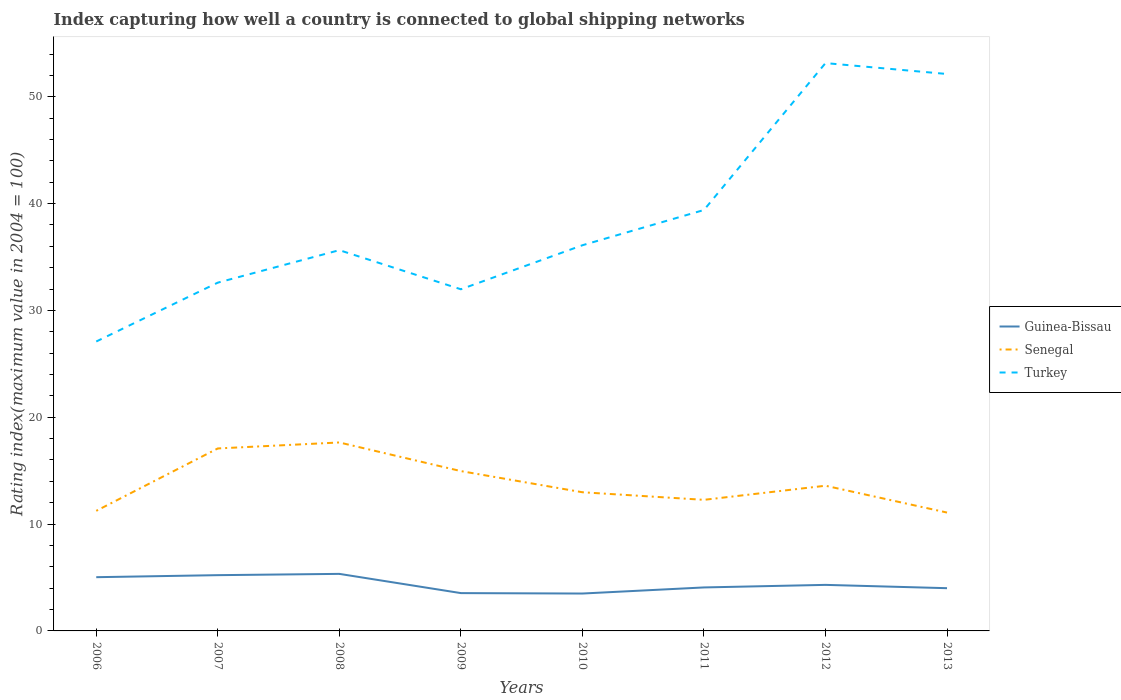How many different coloured lines are there?
Your response must be concise. 3. Across all years, what is the maximum rating index in Turkey?
Provide a short and direct response. 27.09. What is the total rating index in Guinea-Bissau in the graph?
Offer a very short reply. 1.22. What is the difference between the highest and the second highest rating index in Turkey?
Offer a terse response. 26.06. What is the difference between the highest and the lowest rating index in Turkey?
Make the answer very short. 3. How many lines are there?
Your answer should be compact. 3. How many years are there in the graph?
Your answer should be very brief. 8. Are the values on the major ticks of Y-axis written in scientific E-notation?
Offer a very short reply. No. Does the graph contain any zero values?
Ensure brevity in your answer.  No. Does the graph contain grids?
Your answer should be very brief. No. Where does the legend appear in the graph?
Your answer should be compact. Center right. How are the legend labels stacked?
Provide a short and direct response. Vertical. What is the title of the graph?
Offer a terse response. Index capturing how well a country is connected to global shipping networks. What is the label or title of the Y-axis?
Keep it short and to the point. Rating index(maximum value in 2004 = 100). What is the Rating index(maximum value in 2004 = 100) of Guinea-Bissau in 2006?
Offer a very short reply. 5.03. What is the Rating index(maximum value in 2004 = 100) of Senegal in 2006?
Ensure brevity in your answer.  11.24. What is the Rating index(maximum value in 2004 = 100) in Turkey in 2006?
Your answer should be very brief. 27.09. What is the Rating index(maximum value in 2004 = 100) of Guinea-Bissau in 2007?
Offer a terse response. 5.22. What is the Rating index(maximum value in 2004 = 100) in Senegal in 2007?
Give a very brief answer. 17.08. What is the Rating index(maximum value in 2004 = 100) of Turkey in 2007?
Give a very brief answer. 32.6. What is the Rating index(maximum value in 2004 = 100) of Guinea-Bissau in 2008?
Offer a terse response. 5.34. What is the Rating index(maximum value in 2004 = 100) in Senegal in 2008?
Offer a very short reply. 17.64. What is the Rating index(maximum value in 2004 = 100) of Turkey in 2008?
Your answer should be very brief. 35.64. What is the Rating index(maximum value in 2004 = 100) of Guinea-Bissau in 2009?
Make the answer very short. 3.54. What is the Rating index(maximum value in 2004 = 100) in Senegal in 2009?
Your answer should be very brief. 14.96. What is the Rating index(maximum value in 2004 = 100) of Turkey in 2009?
Keep it short and to the point. 31.98. What is the Rating index(maximum value in 2004 = 100) in Guinea-Bissau in 2010?
Make the answer very short. 3.5. What is the Rating index(maximum value in 2004 = 100) in Senegal in 2010?
Offer a very short reply. 12.98. What is the Rating index(maximum value in 2004 = 100) of Turkey in 2010?
Your answer should be compact. 36.1. What is the Rating index(maximum value in 2004 = 100) in Guinea-Bissau in 2011?
Your answer should be compact. 4.07. What is the Rating index(maximum value in 2004 = 100) of Senegal in 2011?
Offer a very short reply. 12.27. What is the Rating index(maximum value in 2004 = 100) in Turkey in 2011?
Offer a terse response. 39.4. What is the Rating index(maximum value in 2004 = 100) of Guinea-Bissau in 2012?
Provide a succinct answer. 4.31. What is the Rating index(maximum value in 2004 = 100) of Senegal in 2012?
Your response must be concise. 13.59. What is the Rating index(maximum value in 2004 = 100) in Turkey in 2012?
Your answer should be compact. 53.15. What is the Rating index(maximum value in 2004 = 100) in Guinea-Bissau in 2013?
Your response must be concise. 4. What is the Rating index(maximum value in 2004 = 100) of Senegal in 2013?
Your answer should be compact. 11.08. What is the Rating index(maximum value in 2004 = 100) of Turkey in 2013?
Your answer should be compact. 52.13. Across all years, what is the maximum Rating index(maximum value in 2004 = 100) of Guinea-Bissau?
Give a very brief answer. 5.34. Across all years, what is the maximum Rating index(maximum value in 2004 = 100) in Senegal?
Your answer should be very brief. 17.64. Across all years, what is the maximum Rating index(maximum value in 2004 = 100) in Turkey?
Your answer should be compact. 53.15. Across all years, what is the minimum Rating index(maximum value in 2004 = 100) in Guinea-Bissau?
Your answer should be very brief. 3.5. Across all years, what is the minimum Rating index(maximum value in 2004 = 100) of Senegal?
Ensure brevity in your answer.  11.08. Across all years, what is the minimum Rating index(maximum value in 2004 = 100) of Turkey?
Ensure brevity in your answer.  27.09. What is the total Rating index(maximum value in 2004 = 100) of Guinea-Bissau in the graph?
Keep it short and to the point. 35.01. What is the total Rating index(maximum value in 2004 = 100) of Senegal in the graph?
Your answer should be compact. 110.84. What is the total Rating index(maximum value in 2004 = 100) of Turkey in the graph?
Your answer should be compact. 308.09. What is the difference between the Rating index(maximum value in 2004 = 100) in Guinea-Bissau in 2006 and that in 2007?
Make the answer very short. -0.19. What is the difference between the Rating index(maximum value in 2004 = 100) of Senegal in 2006 and that in 2007?
Ensure brevity in your answer.  -5.84. What is the difference between the Rating index(maximum value in 2004 = 100) in Turkey in 2006 and that in 2007?
Provide a short and direct response. -5.51. What is the difference between the Rating index(maximum value in 2004 = 100) of Guinea-Bissau in 2006 and that in 2008?
Your answer should be compact. -0.31. What is the difference between the Rating index(maximum value in 2004 = 100) of Senegal in 2006 and that in 2008?
Provide a short and direct response. -6.4. What is the difference between the Rating index(maximum value in 2004 = 100) of Turkey in 2006 and that in 2008?
Make the answer very short. -8.55. What is the difference between the Rating index(maximum value in 2004 = 100) of Guinea-Bissau in 2006 and that in 2009?
Your answer should be compact. 1.49. What is the difference between the Rating index(maximum value in 2004 = 100) in Senegal in 2006 and that in 2009?
Provide a short and direct response. -3.72. What is the difference between the Rating index(maximum value in 2004 = 100) in Turkey in 2006 and that in 2009?
Your answer should be compact. -4.89. What is the difference between the Rating index(maximum value in 2004 = 100) in Guinea-Bissau in 2006 and that in 2010?
Your answer should be very brief. 1.53. What is the difference between the Rating index(maximum value in 2004 = 100) in Senegal in 2006 and that in 2010?
Provide a succinct answer. -1.74. What is the difference between the Rating index(maximum value in 2004 = 100) in Turkey in 2006 and that in 2010?
Your answer should be compact. -9.01. What is the difference between the Rating index(maximum value in 2004 = 100) in Guinea-Bissau in 2006 and that in 2011?
Your response must be concise. 0.96. What is the difference between the Rating index(maximum value in 2004 = 100) in Senegal in 2006 and that in 2011?
Keep it short and to the point. -1.03. What is the difference between the Rating index(maximum value in 2004 = 100) of Turkey in 2006 and that in 2011?
Give a very brief answer. -12.31. What is the difference between the Rating index(maximum value in 2004 = 100) of Guinea-Bissau in 2006 and that in 2012?
Your answer should be very brief. 0.72. What is the difference between the Rating index(maximum value in 2004 = 100) of Senegal in 2006 and that in 2012?
Make the answer very short. -2.35. What is the difference between the Rating index(maximum value in 2004 = 100) in Turkey in 2006 and that in 2012?
Offer a very short reply. -26.06. What is the difference between the Rating index(maximum value in 2004 = 100) in Senegal in 2006 and that in 2013?
Give a very brief answer. 0.16. What is the difference between the Rating index(maximum value in 2004 = 100) in Turkey in 2006 and that in 2013?
Give a very brief answer. -25.04. What is the difference between the Rating index(maximum value in 2004 = 100) of Guinea-Bissau in 2007 and that in 2008?
Give a very brief answer. -0.12. What is the difference between the Rating index(maximum value in 2004 = 100) of Senegal in 2007 and that in 2008?
Give a very brief answer. -0.56. What is the difference between the Rating index(maximum value in 2004 = 100) of Turkey in 2007 and that in 2008?
Ensure brevity in your answer.  -3.04. What is the difference between the Rating index(maximum value in 2004 = 100) of Guinea-Bissau in 2007 and that in 2009?
Make the answer very short. 1.68. What is the difference between the Rating index(maximum value in 2004 = 100) in Senegal in 2007 and that in 2009?
Offer a terse response. 2.12. What is the difference between the Rating index(maximum value in 2004 = 100) of Turkey in 2007 and that in 2009?
Give a very brief answer. 0.62. What is the difference between the Rating index(maximum value in 2004 = 100) of Guinea-Bissau in 2007 and that in 2010?
Your answer should be very brief. 1.72. What is the difference between the Rating index(maximum value in 2004 = 100) of Senegal in 2007 and that in 2010?
Offer a terse response. 4.1. What is the difference between the Rating index(maximum value in 2004 = 100) of Turkey in 2007 and that in 2010?
Your answer should be very brief. -3.5. What is the difference between the Rating index(maximum value in 2004 = 100) in Guinea-Bissau in 2007 and that in 2011?
Your response must be concise. 1.15. What is the difference between the Rating index(maximum value in 2004 = 100) of Senegal in 2007 and that in 2011?
Your answer should be very brief. 4.81. What is the difference between the Rating index(maximum value in 2004 = 100) in Guinea-Bissau in 2007 and that in 2012?
Provide a short and direct response. 0.91. What is the difference between the Rating index(maximum value in 2004 = 100) in Senegal in 2007 and that in 2012?
Ensure brevity in your answer.  3.49. What is the difference between the Rating index(maximum value in 2004 = 100) in Turkey in 2007 and that in 2012?
Your answer should be very brief. -20.55. What is the difference between the Rating index(maximum value in 2004 = 100) in Guinea-Bissau in 2007 and that in 2013?
Your answer should be very brief. 1.22. What is the difference between the Rating index(maximum value in 2004 = 100) in Turkey in 2007 and that in 2013?
Your answer should be very brief. -19.53. What is the difference between the Rating index(maximum value in 2004 = 100) in Guinea-Bissau in 2008 and that in 2009?
Provide a short and direct response. 1.8. What is the difference between the Rating index(maximum value in 2004 = 100) in Senegal in 2008 and that in 2009?
Provide a short and direct response. 2.68. What is the difference between the Rating index(maximum value in 2004 = 100) in Turkey in 2008 and that in 2009?
Ensure brevity in your answer.  3.66. What is the difference between the Rating index(maximum value in 2004 = 100) in Guinea-Bissau in 2008 and that in 2010?
Offer a very short reply. 1.84. What is the difference between the Rating index(maximum value in 2004 = 100) in Senegal in 2008 and that in 2010?
Provide a short and direct response. 4.66. What is the difference between the Rating index(maximum value in 2004 = 100) of Turkey in 2008 and that in 2010?
Give a very brief answer. -0.46. What is the difference between the Rating index(maximum value in 2004 = 100) of Guinea-Bissau in 2008 and that in 2011?
Offer a terse response. 1.27. What is the difference between the Rating index(maximum value in 2004 = 100) in Senegal in 2008 and that in 2011?
Offer a terse response. 5.37. What is the difference between the Rating index(maximum value in 2004 = 100) of Turkey in 2008 and that in 2011?
Keep it short and to the point. -3.76. What is the difference between the Rating index(maximum value in 2004 = 100) of Guinea-Bissau in 2008 and that in 2012?
Provide a succinct answer. 1.03. What is the difference between the Rating index(maximum value in 2004 = 100) of Senegal in 2008 and that in 2012?
Make the answer very short. 4.05. What is the difference between the Rating index(maximum value in 2004 = 100) in Turkey in 2008 and that in 2012?
Ensure brevity in your answer.  -17.51. What is the difference between the Rating index(maximum value in 2004 = 100) in Guinea-Bissau in 2008 and that in 2013?
Provide a succinct answer. 1.34. What is the difference between the Rating index(maximum value in 2004 = 100) in Senegal in 2008 and that in 2013?
Offer a very short reply. 6.56. What is the difference between the Rating index(maximum value in 2004 = 100) of Turkey in 2008 and that in 2013?
Provide a succinct answer. -16.49. What is the difference between the Rating index(maximum value in 2004 = 100) in Guinea-Bissau in 2009 and that in 2010?
Offer a very short reply. 0.04. What is the difference between the Rating index(maximum value in 2004 = 100) in Senegal in 2009 and that in 2010?
Provide a succinct answer. 1.98. What is the difference between the Rating index(maximum value in 2004 = 100) of Turkey in 2009 and that in 2010?
Your response must be concise. -4.12. What is the difference between the Rating index(maximum value in 2004 = 100) of Guinea-Bissau in 2009 and that in 2011?
Your answer should be compact. -0.53. What is the difference between the Rating index(maximum value in 2004 = 100) of Senegal in 2009 and that in 2011?
Offer a very short reply. 2.69. What is the difference between the Rating index(maximum value in 2004 = 100) of Turkey in 2009 and that in 2011?
Provide a short and direct response. -7.42. What is the difference between the Rating index(maximum value in 2004 = 100) in Guinea-Bissau in 2009 and that in 2012?
Offer a very short reply. -0.77. What is the difference between the Rating index(maximum value in 2004 = 100) in Senegal in 2009 and that in 2012?
Ensure brevity in your answer.  1.37. What is the difference between the Rating index(maximum value in 2004 = 100) in Turkey in 2009 and that in 2012?
Ensure brevity in your answer.  -21.17. What is the difference between the Rating index(maximum value in 2004 = 100) in Guinea-Bissau in 2009 and that in 2013?
Your response must be concise. -0.46. What is the difference between the Rating index(maximum value in 2004 = 100) in Senegal in 2009 and that in 2013?
Keep it short and to the point. 3.88. What is the difference between the Rating index(maximum value in 2004 = 100) in Turkey in 2009 and that in 2013?
Give a very brief answer. -20.15. What is the difference between the Rating index(maximum value in 2004 = 100) in Guinea-Bissau in 2010 and that in 2011?
Provide a succinct answer. -0.57. What is the difference between the Rating index(maximum value in 2004 = 100) of Senegal in 2010 and that in 2011?
Keep it short and to the point. 0.71. What is the difference between the Rating index(maximum value in 2004 = 100) in Turkey in 2010 and that in 2011?
Offer a very short reply. -3.3. What is the difference between the Rating index(maximum value in 2004 = 100) in Guinea-Bissau in 2010 and that in 2012?
Provide a short and direct response. -0.81. What is the difference between the Rating index(maximum value in 2004 = 100) in Senegal in 2010 and that in 2012?
Provide a short and direct response. -0.61. What is the difference between the Rating index(maximum value in 2004 = 100) of Turkey in 2010 and that in 2012?
Your response must be concise. -17.05. What is the difference between the Rating index(maximum value in 2004 = 100) in Turkey in 2010 and that in 2013?
Give a very brief answer. -16.03. What is the difference between the Rating index(maximum value in 2004 = 100) in Guinea-Bissau in 2011 and that in 2012?
Offer a very short reply. -0.24. What is the difference between the Rating index(maximum value in 2004 = 100) of Senegal in 2011 and that in 2012?
Offer a very short reply. -1.32. What is the difference between the Rating index(maximum value in 2004 = 100) in Turkey in 2011 and that in 2012?
Your response must be concise. -13.75. What is the difference between the Rating index(maximum value in 2004 = 100) of Guinea-Bissau in 2011 and that in 2013?
Offer a very short reply. 0.07. What is the difference between the Rating index(maximum value in 2004 = 100) in Senegal in 2011 and that in 2013?
Provide a succinct answer. 1.19. What is the difference between the Rating index(maximum value in 2004 = 100) of Turkey in 2011 and that in 2013?
Offer a very short reply. -12.73. What is the difference between the Rating index(maximum value in 2004 = 100) of Guinea-Bissau in 2012 and that in 2013?
Offer a terse response. 0.31. What is the difference between the Rating index(maximum value in 2004 = 100) of Senegal in 2012 and that in 2013?
Your answer should be very brief. 2.51. What is the difference between the Rating index(maximum value in 2004 = 100) of Turkey in 2012 and that in 2013?
Offer a terse response. 1.02. What is the difference between the Rating index(maximum value in 2004 = 100) of Guinea-Bissau in 2006 and the Rating index(maximum value in 2004 = 100) of Senegal in 2007?
Give a very brief answer. -12.05. What is the difference between the Rating index(maximum value in 2004 = 100) in Guinea-Bissau in 2006 and the Rating index(maximum value in 2004 = 100) in Turkey in 2007?
Your response must be concise. -27.57. What is the difference between the Rating index(maximum value in 2004 = 100) of Senegal in 2006 and the Rating index(maximum value in 2004 = 100) of Turkey in 2007?
Your response must be concise. -21.36. What is the difference between the Rating index(maximum value in 2004 = 100) of Guinea-Bissau in 2006 and the Rating index(maximum value in 2004 = 100) of Senegal in 2008?
Give a very brief answer. -12.61. What is the difference between the Rating index(maximum value in 2004 = 100) of Guinea-Bissau in 2006 and the Rating index(maximum value in 2004 = 100) of Turkey in 2008?
Your response must be concise. -30.61. What is the difference between the Rating index(maximum value in 2004 = 100) in Senegal in 2006 and the Rating index(maximum value in 2004 = 100) in Turkey in 2008?
Keep it short and to the point. -24.4. What is the difference between the Rating index(maximum value in 2004 = 100) of Guinea-Bissau in 2006 and the Rating index(maximum value in 2004 = 100) of Senegal in 2009?
Keep it short and to the point. -9.93. What is the difference between the Rating index(maximum value in 2004 = 100) in Guinea-Bissau in 2006 and the Rating index(maximum value in 2004 = 100) in Turkey in 2009?
Your answer should be compact. -26.95. What is the difference between the Rating index(maximum value in 2004 = 100) of Senegal in 2006 and the Rating index(maximum value in 2004 = 100) of Turkey in 2009?
Provide a succinct answer. -20.74. What is the difference between the Rating index(maximum value in 2004 = 100) in Guinea-Bissau in 2006 and the Rating index(maximum value in 2004 = 100) in Senegal in 2010?
Provide a succinct answer. -7.95. What is the difference between the Rating index(maximum value in 2004 = 100) of Guinea-Bissau in 2006 and the Rating index(maximum value in 2004 = 100) of Turkey in 2010?
Offer a terse response. -31.07. What is the difference between the Rating index(maximum value in 2004 = 100) in Senegal in 2006 and the Rating index(maximum value in 2004 = 100) in Turkey in 2010?
Your response must be concise. -24.86. What is the difference between the Rating index(maximum value in 2004 = 100) in Guinea-Bissau in 2006 and the Rating index(maximum value in 2004 = 100) in Senegal in 2011?
Your response must be concise. -7.24. What is the difference between the Rating index(maximum value in 2004 = 100) of Guinea-Bissau in 2006 and the Rating index(maximum value in 2004 = 100) of Turkey in 2011?
Offer a terse response. -34.37. What is the difference between the Rating index(maximum value in 2004 = 100) of Senegal in 2006 and the Rating index(maximum value in 2004 = 100) of Turkey in 2011?
Make the answer very short. -28.16. What is the difference between the Rating index(maximum value in 2004 = 100) in Guinea-Bissau in 2006 and the Rating index(maximum value in 2004 = 100) in Senegal in 2012?
Provide a succinct answer. -8.56. What is the difference between the Rating index(maximum value in 2004 = 100) in Guinea-Bissau in 2006 and the Rating index(maximum value in 2004 = 100) in Turkey in 2012?
Your answer should be very brief. -48.12. What is the difference between the Rating index(maximum value in 2004 = 100) of Senegal in 2006 and the Rating index(maximum value in 2004 = 100) of Turkey in 2012?
Provide a short and direct response. -41.91. What is the difference between the Rating index(maximum value in 2004 = 100) of Guinea-Bissau in 2006 and the Rating index(maximum value in 2004 = 100) of Senegal in 2013?
Ensure brevity in your answer.  -6.05. What is the difference between the Rating index(maximum value in 2004 = 100) in Guinea-Bissau in 2006 and the Rating index(maximum value in 2004 = 100) in Turkey in 2013?
Give a very brief answer. -47.1. What is the difference between the Rating index(maximum value in 2004 = 100) in Senegal in 2006 and the Rating index(maximum value in 2004 = 100) in Turkey in 2013?
Ensure brevity in your answer.  -40.89. What is the difference between the Rating index(maximum value in 2004 = 100) in Guinea-Bissau in 2007 and the Rating index(maximum value in 2004 = 100) in Senegal in 2008?
Keep it short and to the point. -12.42. What is the difference between the Rating index(maximum value in 2004 = 100) of Guinea-Bissau in 2007 and the Rating index(maximum value in 2004 = 100) of Turkey in 2008?
Provide a succinct answer. -30.42. What is the difference between the Rating index(maximum value in 2004 = 100) of Senegal in 2007 and the Rating index(maximum value in 2004 = 100) of Turkey in 2008?
Provide a short and direct response. -18.56. What is the difference between the Rating index(maximum value in 2004 = 100) in Guinea-Bissau in 2007 and the Rating index(maximum value in 2004 = 100) in Senegal in 2009?
Provide a succinct answer. -9.74. What is the difference between the Rating index(maximum value in 2004 = 100) in Guinea-Bissau in 2007 and the Rating index(maximum value in 2004 = 100) in Turkey in 2009?
Give a very brief answer. -26.76. What is the difference between the Rating index(maximum value in 2004 = 100) in Senegal in 2007 and the Rating index(maximum value in 2004 = 100) in Turkey in 2009?
Provide a short and direct response. -14.9. What is the difference between the Rating index(maximum value in 2004 = 100) in Guinea-Bissau in 2007 and the Rating index(maximum value in 2004 = 100) in Senegal in 2010?
Keep it short and to the point. -7.76. What is the difference between the Rating index(maximum value in 2004 = 100) of Guinea-Bissau in 2007 and the Rating index(maximum value in 2004 = 100) of Turkey in 2010?
Offer a very short reply. -30.88. What is the difference between the Rating index(maximum value in 2004 = 100) in Senegal in 2007 and the Rating index(maximum value in 2004 = 100) in Turkey in 2010?
Keep it short and to the point. -19.02. What is the difference between the Rating index(maximum value in 2004 = 100) of Guinea-Bissau in 2007 and the Rating index(maximum value in 2004 = 100) of Senegal in 2011?
Provide a succinct answer. -7.05. What is the difference between the Rating index(maximum value in 2004 = 100) in Guinea-Bissau in 2007 and the Rating index(maximum value in 2004 = 100) in Turkey in 2011?
Provide a succinct answer. -34.18. What is the difference between the Rating index(maximum value in 2004 = 100) of Senegal in 2007 and the Rating index(maximum value in 2004 = 100) of Turkey in 2011?
Offer a very short reply. -22.32. What is the difference between the Rating index(maximum value in 2004 = 100) of Guinea-Bissau in 2007 and the Rating index(maximum value in 2004 = 100) of Senegal in 2012?
Ensure brevity in your answer.  -8.37. What is the difference between the Rating index(maximum value in 2004 = 100) in Guinea-Bissau in 2007 and the Rating index(maximum value in 2004 = 100) in Turkey in 2012?
Offer a terse response. -47.93. What is the difference between the Rating index(maximum value in 2004 = 100) of Senegal in 2007 and the Rating index(maximum value in 2004 = 100) of Turkey in 2012?
Your answer should be very brief. -36.07. What is the difference between the Rating index(maximum value in 2004 = 100) in Guinea-Bissau in 2007 and the Rating index(maximum value in 2004 = 100) in Senegal in 2013?
Your response must be concise. -5.86. What is the difference between the Rating index(maximum value in 2004 = 100) of Guinea-Bissau in 2007 and the Rating index(maximum value in 2004 = 100) of Turkey in 2013?
Offer a terse response. -46.91. What is the difference between the Rating index(maximum value in 2004 = 100) of Senegal in 2007 and the Rating index(maximum value in 2004 = 100) of Turkey in 2013?
Provide a succinct answer. -35.05. What is the difference between the Rating index(maximum value in 2004 = 100) in Guinea-Bissau in 2008 and the Rating index(maximum value in 2004 = 100) in Senegal in 2009?
Give a very brief answer. -9.62. What is the difference between the Rating index(maximum value in 2004 = 100) of Guinea-Bissau in 2008 and the Rating index(maximum value in 2004 = 100) of Turkey in 2009?
Your answer should be very brief. -26.64. What is the difference between the Rating index(maximum value in 2004 = 100) of Senegal in 2008 and the Rating index(maximum value in 2004 = 100) of Turkey in 2009?
Offer a terse response. -14.34. What is the difference between the Rating index(maximum value in 2004 = 100) in Guinea-Bissau in 2008 and the Rating index(maximum value in 2004 = 100) in Senegal in 2010?
Provide a succinct answer. -7.64. What is the difference between the Rating index(maximum value in 2004 = 100) in Guinea-Bissau in 2008 and the Rating index(maximum value in 2004 = 100) in Turkey in 2010?
Offer a very short reply. -30.76. What is the difference between the Rating index(maximum value in 2004 = 100) of Senegal in 2008 and the Rating index(maximum value in 2004 = 100) of Turkey in 2010?
Offer a terse response. -18.46. What is the difference between the Rating index(maximum value in 2004 = 100) of Guinea-Bissau in 2008 and the Rating index(maximum value in 2004 = 100) of Senegal in 2011?
Your answer should be compact. -6.93. What is the difference between the Rating index(maximum value in 2004 = 100) in Guinea-Bissau in 2008 and the Rating index(maximum value in 2004 = 100) in Turkey in 2011?
Provide a succinct answer. -34.06. What is the difference between the Rating index(maximum value in 2004 = 100) of Senegal in 2008 and the Rating index(maximum value in 2004 = 100) of Turkey in 2011?
Ensure brevity in your answer.  -21.76. What is the difference between the Rating index(maximum value in 2004 = 100) of Guinea-Bissau in 2008 and the Rating index(maximum value in 2004 = 100) of Senegal in 2012?
Your answer should be compact. -8.25. What is the difference between the Rating index(maximum value in 2004 = 100) in Guinea-Bissau in 2008 and the Rating index(maximum value in 2004 = 100) in Turkey in 2012?
Give a very brief answer. -47.81. What is the difference between the Rating index(maximum value in 2004 = 100) in Senegal in 2008 and the Rating index(maximum value in 2004 = 100) in Turkey in 2012?
Offer a terse response. -35.51. What is the difference between the Rating index(maximum value in 2004 = 100) of Guinea-Bissau in 2008 and the Rating index(maximum value in 2004 = 100) of Senegal in 2013?
Provide a short and direct response. -5.74. What is the difference between the Rating index(maximum value in 2004 = 100) of Guinea-Bissau in 2008 and the Rating index(maximum value in 2004 = 100) of Turkey in 2013?
Make the answer very short. -46.79. What is the difference between the Rating index(maximum value in 2004 = 100) in Senegal in 2008 and the Rating index(maximum value in 2004 = 100) in Turkey in 2013?
Provide a short and direct response. -34.49. What is the difference between the Rating index(maximum value in 2004 = 100) in Guinea-Bissau in 2009 and the Rating index(maximum value in 2004 = 100) in Senegal in 2010?
Offer a very short reply. -9.44. What is the difference between the Rating index(maximum value in 2004 = 100) of Guinea-Bissau in 2009 and the Rating index(maximum value in 2004 = 100) of Turkey in 2010?
Keep it short and to the point. -32.56. What is the difference between the Rating index(maximum value in 2004 = 100) in Senegal in 2009 and the Rating index(maximum value in 2004 = 100) in Turkey in 2010?
Keep it short and to the point. -21.14. What is the difference between the Rating index(maximum value in 2004 = 100) of Guinea-Bissau in 2009 and the Rating index(maximum value in 2004 = 100) of Senegal in 2011?
Make the answer very short. -8.73. What is the difference between the Rating index(maximum value in 2004 = 100) in Guinea-Bissau in 2009 and the Rating index(maximum value in 2004 = 100) in Turkey in 2011?
Offer a very short reply. -35.86. What is the difference between the Rating index(maximum value in 2004 = 100) in Senegal in 2009 and the Rating index(maximum value in 2004 = 100) in Turkey in 2011?
Ensure brevity in your answer.  -24.44. What is the difference between the Rating index(maximum value in 2004 = 100) in Guinea-Bissau in 2009 and the Rating index(maximum value in 2004 = 100) in Senegal in 2012?
Give a very brief answer. -10.05. What is the difference between the Rating index(maximum value in 2004 = 100) in Guinea-Bissau in 2009 and the Rating index(maximum value in 2004 = 100) in Turkey in 2012?
Provide a succinct answer. -49.61. What is the difference between the Rating index(maximum value in 2004 = 100) in Senegal in 2009 and the Rating index(maximum value in 2004 = 100) in Turkey in 2012?
Provide a succinct answer. -38.19. What is the difference between the Rating index(maximum value in 2004 = 100) of Guinea-Bissau in 2009 and the Rating index(maximum value in 2004 = 100) of Senegal in 2013?
Your response must be concise. -7.54. What is the difference between the Rating index(maximum value in 2004 = 100) of Guinea-Bissau in 2009 and the Rating index(maximum value in 2004 = 100) of Turkey in 2013?
Make the answer very short. -48.59. What is the difference between the Rating index(maximum value in 2004 = 100) in Senegal in 2009 and the Rating index(maximum value in 2004 = 100) in Turkey in 2013?
Offer a terse response. -37.17. What is the difference between the Rating index(maximum value in 2004 = 100) in Guinea-Bissau in 2010 and the Rating index(maximum value in 2004 = 100) in Senegal in 2011?
Your response must be concise. -8.77. What is the difference between the Rating index(maximum value in 2004 = 100) in Guinea-Bissau in 2010 and the Rating index(maximum value in 2004 = 100) in Turkey in 2011?
Your response must be concise. -35.9. What is the difference between the Rating index(maximum value in 2004 = 100) in Senegal in 2010 and the Rating index(maximum value in 2004 = 100) in Turkey in 2011?
Make the answer very short. -26.42. What is the difference between the Rating index(maximum value in 2004 = 100) of Guinea-Bissau in 2010 and the Rating index(maximum value in 2004 = 100) of Senegal in 2012?
Provide a succinct answer. -10.09. What is the difference between the Rating index(maximum value in 2004 = 100) of Guinea-Bissau in 2010 and the Rating index(maximum value in 2004 = 100) of Turkey in 2012?
Your response must be concise. -49.65. What is the difference between the Rating index(maximum value in 2004 = 100) of Senegal in 2010 and the Rating index(maximum value in 2004 = 100) of Turkey in 2012?
Your answer should be very brief. -40.17. What is the difference between the Rating index(maximum value in 2004 = 100) in Guinea-Bissau in 2010 and the Rating index(maximum value in 2004 = 100) in Senegal in 2013?
Your answer should be very brief. -7.58. What is the difference between the Rating index(maximum value in 2004 = 100) in Guinea-Bissau in 2010 and the Rating index(maximum value in 2004 = 100) in Turkey in 2013?
Provide a succinct answer. -48.63. What is the difference between the Rating index(maximum value in 2004 = 100) of Senegal in 2010 and the Rating index(maximum value in 2004 = 100) of Turkey in 2013?
Provide a short and direct response. -39.15. What is the difference between the Rating index(maximum value in 2004 = 100) in Guinea-Bissau in 2011 and the Rating index(maximum value in 2004 = 100) in Senegal in 2012?
Keep it short and to the point. -9.52. What is the difference between the Rating index(maximum value in 2004 = 100) in Guinea-Bissau in 2011 and the Rating index(maximum value in 2004 = 100) in Turkey in 2012?
Provide a short and direct response. -49.08. What is the difference between the Rating index(maximum value in 2004 = 100) of Senegal in 2011 and the Rating index(maximum value in 2004 = 100) of Turkey in 2012?
Your response must be concise. -40.88. What is the difference between the Rating index(maximum value in 2004 = 100) of Guinea-Bissau in 2011 and the Rating index(maximum value in 2004 = 100) of Senegal in 2013?
Offer a terse response. -7.01. What is the difference between the Rating index(maximum value in 2004 = 100) in Guinea-Bissau in 2011 and the Rating index(maximum value in 2004 = 100) in Turkey in 2013?
Offer a very short reply. -48.06. What is the difference between the Rating index(maximum value in 2004 = 100) in Senegal in 2011 and the Rating index(maximum value in 2004 = 100) in Turkey in 2013?
Your answer should be very brief. -39.86. What is the difference between the Rating index(maximum value in 2004 = 100) in Guinea-Bissau in 2012 and the Rating index(maximum value in 2004 = 100) in Senegal in 2013?
Your answer should be very brief. -6.77. What is the difference between the Rating index(maximum value in 2004 = 100) in Guinea-Bissau in 2012 and the Rating index(maximum value in 2004 = 100) in Turkey in 2013?
Provide a succinct answer. -47.82. What is the difference between the Rating index(maximum value in 2004 = 100) in Senegal in 2012 and the Rating index(maximum value in 2004 = 100) in Turkey in 2013?
Offer a terse response. -38.54. What is the average Rating index(maximum value in 2004 = 100) of Guinea-Bissau per year?
Provide a succinct answer. 4.38. What is the average Rating index(maximum value in 2004 = 100) in Senegal per year?
Provide a succinct answer. 13.86. What is the average Rating index(maximum value in 2004 = 100) in Turkey per year?
Offer a very short reply. 38.51. In the year 2006, what is the difference between the Rating index(maximum value in 2004 = 100) in Guinea-Bissau and Rating index(maximum value in 2004 = 100) in Senegal?
Your answer should be compact. -6.21. In the year 2006, what is the difference between the Rating index(maximum value in 2004 = 100) in Guinea-Bissau and Rating index(maximum value in 2004 = 100) in Turkey?
Offer a very short reply. -22.06. In the year 2006, what is the difference between the Rating index(maximum value in 2004 = 100) in Senegal and Rating index(maximum value in 2004 = 100) in Turkey?
Keep it short and to the point. -15.85. In the year 2007, what is the difference between the Rating index(maximum value in 2004 = 100) of Guinea-Bissau and Rating index(maximum value in 2004 = 100) of Senegal?
Your answer should be very brief. -11.86. In the year 2007, what is the difference between the Rating index(maximum value in 2004 = 100) in Guinea-Bissau and Rating index(maximum value in 2004 = 100) in Turkey?
Offer a terse response. -27.38. In the year 2007, what is the difference between the Rating index(maximum value in 2004 = 100) of Senegal and Rating index(maximum value in 2004 = 100) of Turkey?
Offer a very short reply. -15.52. In the year 2008, what is the difference between the Rating index(maximum value in 2004 = 100) of Guinea-Bissau and Rating index(maximum value in 2004 = 100) of Turkey?
Provide a succinct answer. -30.3. In the year 2008, what is the difference between the Rating index(maximum value in 2004 = 100) of Senegal and Rating index(maximum value in 2004 = 100) of Turkey?
Your answer should be very brief. -18. In the year 2009, what is the difference between the Rating index(maximum value in 2004 = 100) in Guinea-Bissau and Rating index(maximum value in 2004 = 100) in Senegal?
Provide a succinct answer. -11.42. In the year 2009, what is the difference between the Rating index(maximum value in 2004 = 100) of Guinea-Bissau and Rating index(maximum value in 2004 = 100) of Turkey?
Give a very brief answer. -28.44. In the year 2009, what is the difference between the Rating index(maximum value in 2004 = 100) in Senegal and Rating index(maximum value in 2004 = 100) in Turkey?
Keep it short and to the point. -17.02. In the year 2010, what is the difference between the Rating index(maximum value in 2004 = 100) of Guinea-Bissau and Rating index(maximum value in 2004 = 100) of Senegal?
Make the answer very short. -9.48. In the year 2010, what is the difference between the Rating index(maximum value in 2004 = 100) in Guinea-Bissau and Rating index(maximum value in 2004 = 100) in Turkey?
Provide a succinct answer. -32.6. In the year 2010, what is the difference between the Rating index(maximum value in 2004 = 100) of Senegal and Rating index(maximum value in 2004 = 100) of Turkey?
Give a very brief answer. -23.12. In the year 2011, what is the difference between the Rating index(maximum value in 2004 = 100) of Guinea-Bissau and Rating index(maximum value in 2004 = 100) of Senegal?
Make the answer very short. -8.2. In the year 2011, what is the difference between the Rating index(maximum value in 2004 = 100) in Guinea-Bissau and Rating index(maximum value in 2004 = 100) in Turkey?
Keep it short and to the point. -35.33. In the year 2011, what is the difference between the Rating index(maximum value in 2004 = 100) of Senegal and Rating index(maximum value in 2004 = 100) of Turkey?
Give a very brief answer. -27.13. In the year 2012, what is the difference between the Rating index(maximum value in 2004 = 100) in Guinea-Bissau and Rating index(maximum value in 2004 = 100) in Senegal?
Keep it short and to the point. -9.28. In the year 2012, what is the difference between the Rating index(maximum value in 2004 = 100) in Guinea-Bissau and Rating index(maximum value in 2004 = 100) in Turkey?
Offer a very short reply. -48.84. In the year 2012, what is the difference between the Rating index(maximum value in 2004 = 100) of Senegal and Rating index(maximum value in 2004 = 100) of Turkey?
Provide a succinct answer. -39.56. In the year 2013, what is the difference between the Rating index(maximum value in 2004 = 100) in Guinea-Bissau and Rating index(maximum value in 2004 = 100) in Senegal?
Your response must be concise. -7.08. In the year 2013, what is the difference between the Rating index(maximum value in 2004 = 100) in Guinea-Bissau and Rating index(maximum value in 2004 = 100) in Turkey?
Give a very brief answer. -48.13. In the year 2013, what is the difference between the Rating index(maximum value in 2004 = 100) in Senegal and Rating index(maximum value in 2004 = 100) in Turkey?
Keep it short and to the point. -41.05. What is the ratio of the Rating index(maximum value in 2004 = 100) of Guinea-Bissau in 2006 to that in 2007?
Give a very brief answer. 0.96. What is the ratio of the Rating index(maximum value in 2004 = 100) in Senegal in 2006 to that in 2007?
Provide a succinct answer. 0.66. What is the ratio of the Rating index(maximum value in 2004 = 100) of Turkey in 2006 to that in 2007?
Keep it short and to the point. 0.83. What is the ratio of the Rating index(maximum value in 2004 = 100) in Guinea-Bissau in 2006 to that in 2008?
Offer a very short reply. 0.94. What is the ratio of the Rating index(maximum value in 2004 = 100) in Senegal in 2006 to that in 2008?
Give a very brief answer. 0.64. What is the ratio of the Rating index(maximum value in 2004 = 100) in Turkey in 2006 to that in 2008?
Provide a short and direct response. 0.76. What is the ratio of the Rating index(maximum value in 2004 = 100) of Guinea-Bissau in 2006 to that in 2009?
Your response must be concise. 1.42. What is the ratio of the Rating index(maximum value in 2004 = 100) of Senegal in 2006 to that in 2009?
Your response must be concise. 0.75. What is the ratio of the Rating index(maximum value in 2004 = 100) of Turkey in 2006 to that in 2009?
Keep it short and to the point. 0.85. What is the ratio of the Rating index(maximum value in 2004 = 100) of Guinea-Bissau in 2006 to that in 2010?
Offer a terse response. 1.44. What is the ratio of the Rating index(maximum value in 2004 = 100) of Senegal in 2006 to that in 2010?
Give a very brief answer. 0.87. What is the ratio of the Rating index(maximum value in 2004 = 100) in Turkey in 2006 to that in 2010?
Your answer should be compact. 0.75. What is the ratio of the Rating index(maximum value in 2004 = 100) of Guinea-Bissau in 2006 to that in 2011?
Your response must be concise. 1.24. What is the ratio of the Rating index(maximum value in 2004 = 100) of Senegal in 2006 to that in 2011?
Keep it short and to the point. 0.92. What is the ratio of the Rating index(maximum value in 2004 = 100) of Turkey in 2006 to that in 2011?
Offer a very short reply. 0.69. What is the ratio of the Rating index(maximum value in 2004 = 100) in Guinea-Bissau in 2006 to that in 2012?
Your answer should be compact. 1.17. What is the ratio of the Rating index(maximum value in 2004 = 100) of Senegal in 2006 to that in 2012?
Offer a very short reply. 0.83. What is the ratio of the Rating index(maximum value in 2004 = 100) of Turkey in 2006 to that in 2012?
Keep it short and to the point. 0.51. What is the ratio of the Rating index(maximum value in 2004 = 100) in Guinea-Bissau in 2006 to that in 2013?
Keep it short and to the point. 1.26. What is the ratio of the Rating index(maximum value in 2004 = 100) of Senegal in 2006 to that in 2013?
Provide a succinct answer. 1.01. What is the ratio of the Rating index(maximum value in 2004 = 100) in Turkey in 2006 to that in 2013?
Make the answer very short. 0.52. What is the ratio of the Rating index(maximum value in 2004 = 100) in Guinea-Bissau in 2007 to that in 2008?
Your answer should be very brief. 0.98. What is the ratio of the Rating index(maximum value in 2004 = 100) of Senegal in 2007 to that in 2008?
Make the answer very short. 0.97. What is the ratio of the Rating index(maximum value in 2004 = 100) of Turkey in 2007 to that in 2008?
Give a very brief answer. 0.91. What is the ratio of the Rating index(maximum value in 2004 = 100) in Guinea-Bissau in 2007 to that in 2009?
Make the answer very short. 1.47. What is the ratio of the Rating index(maximum value in 2004 = 100) in Senegal in 2007 to that in 2009?
Your answer should be very brief. 1.14. What is the ratio of the Rating index(maximum value in 2004 = 100) of Turkey in 2007 to that in 2009?
Your answer should be very brief. 1.02. What is the ratio of the Rating index(maximum value in 2004 = 100) of Guinea-Bissau in 2007 to that in 2010?
Offer a terse response. 1.49. What is the ratio of the Rating index(maximum value in 2004 = 100) in Senegal in 2007 to that in 2010?
Your answer should be compact. 1.32. What is the ratio of the Rating index(maximum value in 2004 = 100) of Turkey in 2007 to that in 2010?
Provide a succinct answer. 0.9. What is the ratio of the Rating index(maximum value in 2004 = 100) in Guinea-Bissau in 2007 to that in 2011?
Provide a succinct answer. 1.28. What is the ratio of the Rating index(maximum value in 2004 = 100) of Senegal in 2007 to that in 2011?
Your response must be concise. 1.39. What is the ratio of the Rating index(maximum value in 2004 = 100) of Turkey in 2007 to that in 2011?
Make the answer very short. 0.83. What is the ratio of the Rating index(maximum value in 2004 = 100) in Guinea-Bissau in 2007 to that in 2012?
Keep it short and to the point. 1.21. What is the ratio of the Rating index(maximum value in 2004 = 100) in Senegal in 2007 to that in 2012?
Keep it short and to the point. 1.26. What is the ratio of the Rating index(maximum value in 2004 = 100) in Turkey in 2007 to that in 2012?
Your response must be concise. 0.61. What is the ratio of the Rating index(maximum value in 2004 = 100) of Guinea-Bissau in 2007 to that in 2013?
Ensure brevity in your answer.  1.3. What is the ratio of the Rating index(maximum value in 2004 = 100) in Senegal in 2007 to that in 2013?
Your response must be concise. 1.54. What is the ratio of the Rating index(maximum value in 2004 = 100) of Turkey in 2007 to that in 2013?
Your answer should be very brief. 0.63. What is the ratio of the Rating index(maximum value in 2004 = 100) in Guinea-Bissau in 2008 to that in 2009?
Make the answer very short. 1.51. What is the ratio of the Rating index(maximum value in 2004 = 100) of Senegal in 2008 to that in 2009?
Your answer should be compact. 1.18. What is the ratio of the Rating index(maximum value in 2004 = 100) in Turkey in 2008 to that in 2009?
Offer a very short reply. 1.11. What is the ratio of the Rating index(maximum value in 2004 = 100) of Guinea-Bissau in 2008 to that in 2010?
Offer a terse response. 1.53. What is the ratio of the Rating index(maximum value in 2004 = 100) in Senegal in 2008 to that in 2010?
Provide a short and direct response. 1.36. What is the ratio of the Rating index(maximum value in 2004 = 100) in Turkey in 2008 to that in 2010?
Make the answer very short. 0.99. What is the ratio of the Rating index(maximum value in 2004 = 100) in Guinea-Bissau in 2008 to that in 2011?
Make the answer very short. 1.31. What is the ratio of the Rating index(maximum value in 2004 = 100) of Senegal in 2008 to that in 2011?
Your answer should be very brief. 1.44. What is the ratio of the Rating index(maximum value in 2004 = 100) of Turkey in 2008 to that in 2011?
Keep it short and to the point. 0.9. What is the ratio of the Rating index(maximum value in 2004 = 100) of Guinea-Bissau in 2008 to that in 2012?
Provide a short and direct response. 1.24. What is the ratio of the Rating index(maximum value in 2004 = 100) of Senegal in 2008 to that in 2012?
Your answer should be very brief. 1.3. What is the ratio of the Rating index(maximum value in 2004 = 100) in Turkey in 2008 to that in 2012?
Make the answer very short. 0.67. What is the ratio of the Rating index(maximum value in 2004 = 100) of Guinea-Bissau in 2008 to that in 2013?
Your response must be concise. 1.33. What is the ratio of the Rating index(maximum value in 2004 = 100) in Senegal in 2008 to that in 2013?
Give a very brief answer. 1.59. What is the ratio of the Rating index(maximum value in 2004 = 100) in Turkey in 2008 to that in 2013?
Offer a terse response. 0.68. What is the ratio of the Rating index(maximum value in 2004 = 100) of Guinea-Bissau in 2009 to that in 2010?
Ensure brevity in your answer.  1.01. What is the ratio of the Rating index(maximum value in 2004 = 100) of Senegal in 2009 to that in 2010?
Provide a short and direct response. 1.15. What is the ratio of the Rating index(maximum value in 2004 = 100) in Turkey in 2009 to that in 2010?
Your response must be concise. 0.89. What is the ratio of the Rating index(maximum value in 2004 = 100) in Guinea-Bissau in 2009 to that in 2011?
Make the answer very short. 0.87. What is the ratio of the Rating index(maximum value in 2004 = 100) in Senegal in 2009 to that in 2011?
Your answer should be very brief. 1.22. What is the ratio of the Rating index(maximum value in 2004 = 100) in Turkey in 2009 to that in 2011?
Provide a short and direct response. 0.81. What is the ratio of the Rating index(maximum value in 2004 = 100) in Guinea-Bissau in 2009 to that in 2012?
Give a very brief answer. 0.82. What is the ratio of the Rating index(maximum value in 2004 = 100) in Senegal in 2009 to that in 2012?
Provide a short and direct response. 1.1. What is the ratio of the Rating index(maximum value in 2004 = 100) of Turkey in 2009 to that in 2012?
Provide a short and direct response. 0.6. What is the ratio of the Rating index(maximum value in 2004 = 100) of Guinea-Bissau in 2009 to that in 2013?
Give a very brief answer. 0.89. What is the ratio of the Rating index(maximum value in 2004 = 100) in Senegal in 2009 to that in 2013?
Provide a succinct answer. 1.35. What is the ratio of the Rating index(maximum value in 2004 = 100) in Turkey in 2009 to that in 2013?
Give a very brief answer. 0.61. What is the ratio of the Rating index(maximum value in 2004 = 100) of Guinea-Bissau in 2010 to that in 2011?
Give a very brief answer. 0.86. What is the ratio of the Rating index(maximum value in 2004 = 100) in Senegal in 2010 to that in 2011?
Make the answer very short. 1.06. What is the ratio of the Rating index(maximum value in 2004 = 100) in Turkey in 2010 to that in 2011?
Your answer should be very brief. 0.92. What is the ratio of the Rating index(maximum value in 2004 = 100) of Guinea-Bissau in 2010 to that in 2012?
Give a very brief answer. 0.81. What is the ratio of the Rating index(maximum value in 2004 = 100) of Senegal in 2010 to that in 2012?
Offer a terse response. 0.96. What is the ratio of the Rating index(maximum value in 2004 = 100) in Turkey in 2010 to that in 2012?
Provide a short and direct response. 0.68. What is the ratio of the Rating index(maximum value in 2004 = 100) of Senegal in 2010 to that in 2013?
Your response must be concise. 1.17. What is the ratio of the Rating index(maximum value in 2004 = 100) in Turkey in 2010 to that in 2013?
Your answer should be compact. 0.69. What is the ratio of the Rating index(maximum value in 2004 = 100) in Guinea-Bissau in 2011 to that in 2012?
Provide a succinct answer. 0.94. What is the ratio of the Rating index(maximum value in 2004 = 100) of Senegal in 2011 to that in 2012?
Provide a short and direct response. 0.9. What is the ratio of the Rating index(maximum value in 2004 = 100) of Turkey in 2011 to that in 2012?
Provide a succinct answer. 0.74. What is the ratio of the Rating index(maximum value in 2004 = 100) of Guinea-Bissau in 2011 to that in 2013?
Provide a succinct answer. 1.02. What is the ratio of the Rating index(maximum value in 2004 = 100) of Senegal in 2011 to that in 2013?
Your answer should be compact. 1.11. What is the ratio of the Rating index(maximum value in 2004 = 100) in Turkey in 2011 to that in 2013?
Your response must be concise. 0.76. What is the ratio of the Rating index(maximum value in 2004 = 100) of Guinea-Bissau in 2012 to that in 2013?
Provide a succinct answer. 1.08. What is the ratio of the Rating index(maximum value in 2004 = 100) of Senegal in 2012 to that in 2013?
Ensure brevity in your answer.  1.23. What is the ratio of the Rating index(maximum value in 2004 = 100) in Turkey in 2012 to that in 2013?
Provide a short and direct response. 1.02. What is the difference between the highest and the second highest Rating index(maximum value in 2004 = 100) in Guinea-Bissau?
Provide a short and direct response. 0.12. What is the difference between the highest and the second highest Rating index(maximum value in 2004 = 100) of Senegal?
Give a very brief answer. 0.56. What is the difference between the highest and the lowest Rating index(maximum value in 2004 = 100) of Guinea-Bissau?
Your answer should be compact. 1.84. What is the difference between the highest and the lowest Rating index(maximum value in 2004 = 100) in Senegal?
Provide a succinct answer. 6.56. What is the difference between the highest and the lowest Rating index(maximum value in 2004 = 100) of Turkey?
Your response must be concise. 26.06. 